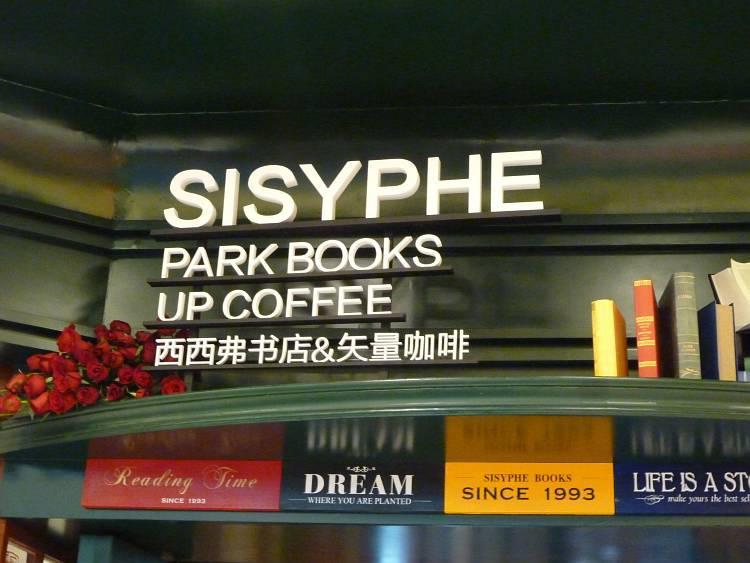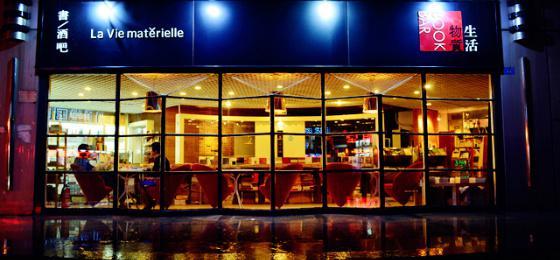The first image is the image on the left, the second image is the image on the right. Examine the images to the left and right. Is the description "Each image shows the outside window of the business." accurate? Answer yes or no. Yes. The first image is the image on the left, the second image is the image on the right. Assess this claim about the two images: "There are people sitting.". Correct or not? Answer yes or no. Yes. 